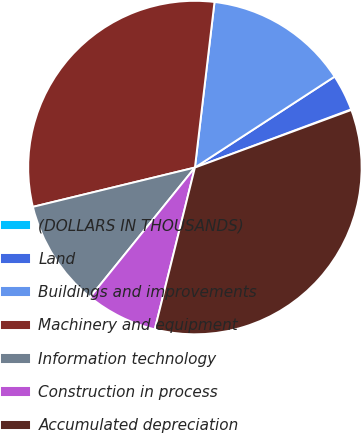Convert chart to OTSL. <chart><loc_0><loc_0><loc_500><loc_500><pie_chart><fcel>(DOLLARS IN THOUSANDS)<fcel>Land<fcel>Buildings and improvements<fcel>Machinery and equipment<fcel>Information technology<fcel>Construction in process<fcel>Accumulated depreciation<nl><fcel>0.06%<fcel>3.51%<fcel>13.94%<fcel>30.66%<fcel>10.39%<fcel>6.95%<fcel>34.48%<nl></chart> 